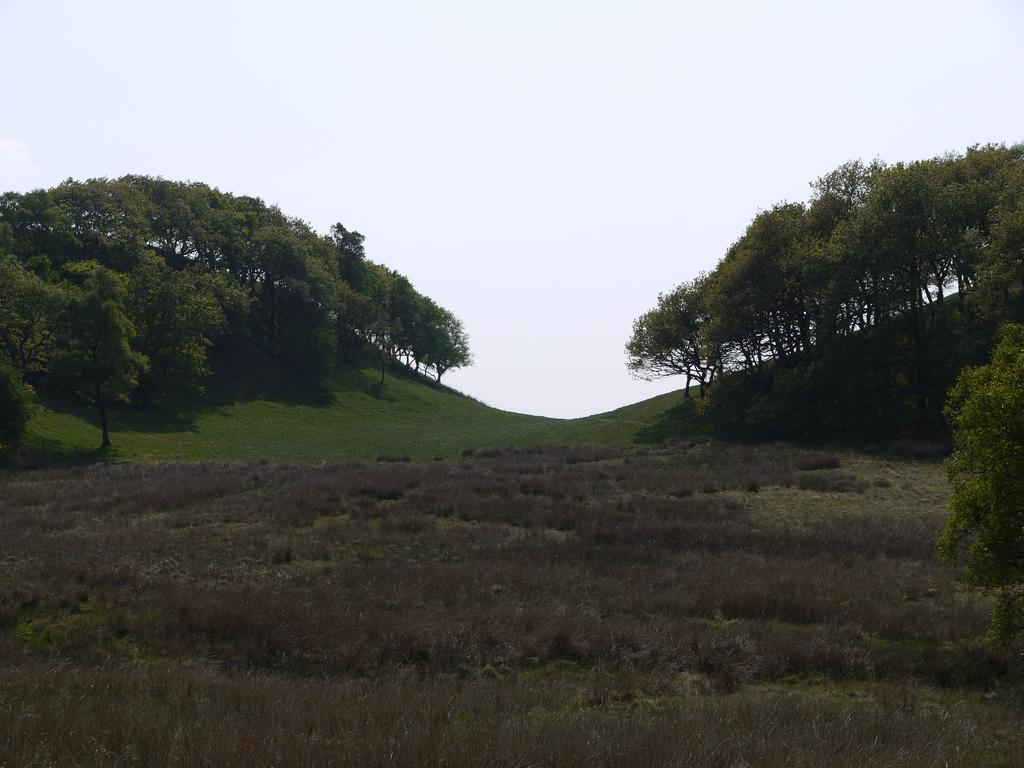What type of vegetation is present in the image? There are trees in the image. What other natural elements can be seen in the image? There is grass in the image. What is visible in the background of the image? The sky is visible in the image. Can you see a boy touching the trees in the image? There is no boy present in the image, and therefore no one is touching the trees. 